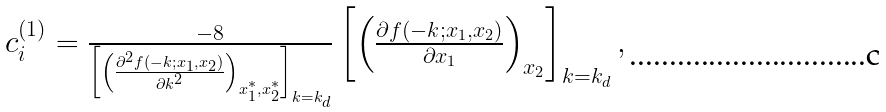Convert formula to latex. <formula><loc_0><loc_0><loc_500><loc_500>\begin{array} { c } c ^ { ( 1 ) } _ { i } = \frac { - 8 } { \left [ \left ( \frac { \partial ^ { 2 } f ( - k ; x _ { 1 } , x _ { 2 } ) } { \partial k ^ { 2 } } \right ) _ { x ^ { * } _ { 1 } , x ^ { * } _ { 2 } } \right ] _ { k = k _ { d } } } \left [ \left ( \frac { \partial f ( - k ; x _ { 1 } , x _ { 2 } ) } { \partial x _ { 1 } } \right ) _ { x _ { 2 } } \right ] _ { k = k _ { d } } , \end{array}</formula> 